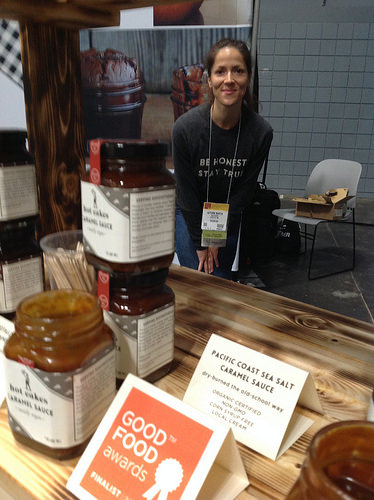<image>
Is the woman behind the table? Yes. From this viewpoint, the woman is positioned behind the table, with the table partially or fully occluding the woman. 